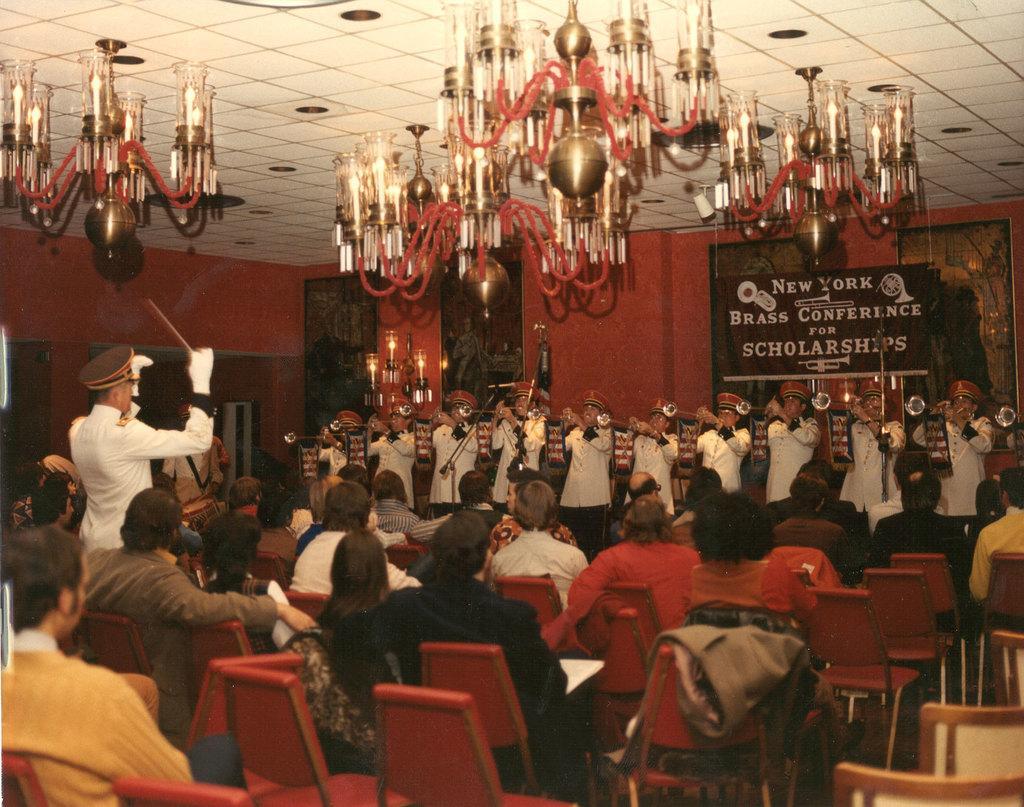Describe this image in one or two sentences. In this image we can see some people sitting on the chairs. On the backside we can see an orchestra and a person managing them. We can also see some ceiling lights, board, wall and frames. 